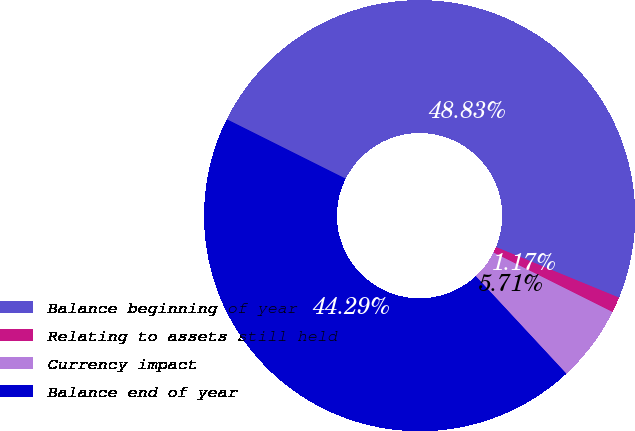<chart> <loc_0><loc_0><loc_500><loc_500><pie_chart><fcel>Balance beginning of year<fcel>Relating to assets still held<fcel>Currency impact<fcel>Balance end of year<nl><fcel>48.83%<fcel>1.17%<fcel>5.71%<fcel>44.29%<nl></chart> 